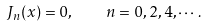Convert formula to latex. <formula><loc_0><loc_0><loc_500><loc_500>J _ { n } ( x ) = 0 , \quad n = 0 , 2 , 4 , \cdots .</formula> 